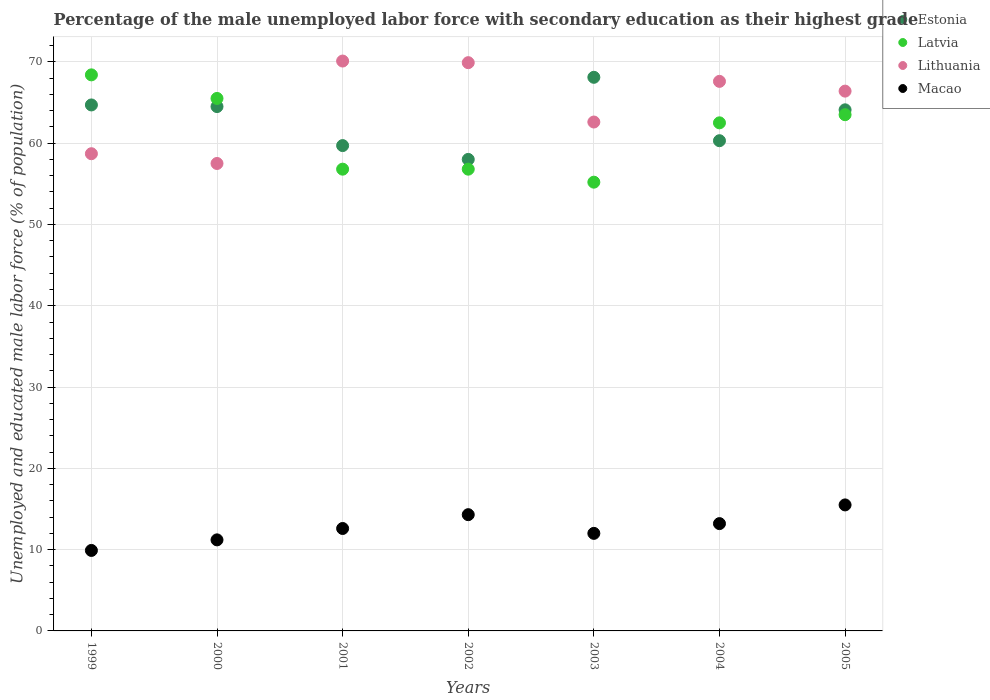Is the number of dotlines equal to the number of legend labels?
Your response must be concise. Yes. What is the percentage of the unemployed male labor force with secondary education in Macao in 2001?
Provide a succinct answer. 12.6. Across all years, what is the maximum percentage of the unemployed male labor force with secondary education in Estonia?
Keep it short and to the point. 68.1. In which year was the percentage of the unemployed male labor force with secondary education in Lithuania maximum?
Make the answer very short. 2001. In which year was the percentage of the unemployed male labor force with secondary education in Lithuania minimum?
Make the answer very short. 2000. What is the total percentage of the unemployed male labor force with secondary education in Lithuania in the graph?
Give a very brief answer. 452.8. What is the difference between the percentage of the unemployed male labor force with secondary education in Macao in 2003 and that in 2005?
Ensure brevity in your answer.  -3.5. What is the difference between the percentage of the unemployed male labor force with secondary education in Lithuania in 2004 and the percentage of the unemployed male labor force with secondary education in Macao in 2003?
Offer a terse response. 55.6. What is the average percentage of the unemployed male labor force with secondary education in Macao per year?
Make the answer very short. 12.67. In the year 2002, what is the difference between the percentage of the unemployed male labor force with secondary education in Macao and percentage of the unemployed male labor force with secondary education in Latvia?
Ensure brevity in your answer.  -42.5. In how many years, is the percentage of the unemployed male labor force with secondary education in Estonia greater than 68 %?
Offer a terse response. 1. What is the ratio of the percentage of the unemployed male labor force with secondary education in Estonia in 1999 to that in 2005?
Give a very brief answer. 1.01. Is the percentage of the unemployed male labor force with secondary education in Latvia in 1999 less than that in 2000?
Make the answer very short. No. What is the difference between the highest and the second highest percentage of the unemployed male labor force with secondary education in Macao?
Keep it short and to the point. 1.2. What is the difference between the highest and the lowest percentage of the unemployed male labor force with secondary education in Estonia?
Keep it short and to the point. 10.1. Is the sum of the percentage of the unemployed male labor force with secondary education in Estonia in 2000 and 2003 greater than the maximum percentage of the unemployed male labor force with secondary education in Lithuania across all years?
Offer a very short reply. Yes. Is it the case that in every year, the sum of the percentage of the unemployed male labor force with secondary education in Lithuania and percentage of the unemployed male labor force with secondary education in Estonia  is greater than the sum of percentage of the unemployed male labor force with secondary education in Latvia and percentage of the unemployed male labor force with secondary education in Macao?
Your response must be concise. No. Is it the case that in every year, the sum of the percentage of the unemployed male labor force with secondary education in Estonia and percentage of the unemployed male labor force with secondary education in Latvia  is greater than the percentage of the unemployed male labor force with secondary education in Lithuania?
Offer a terse response. Yes. Is the percentage of the unemployed male labor force with secondary education in Macao strictly greater than the percentage of the unemployed male labor force with secondary education in Estonia over the years?
Keep it short and to the point. No. How many dotlines are there?
Your response must be concise. 4. How many years are there in the graph?
Provide a succinct answer. 7. Are the values on the major ticks of Y-axis written in scientific E-notation?
Your answer should be very brief. No. Does the graph contain any zero values?
Your response must be concise. No. Does the graph contain grids?
Your response must be concise. Yes. Where does the legend appear in the graph?
Offer a very short reply. Top right. What is the title of the graph?
Your response must be concise. Percentage of the male unemployed labor force with secondary education as their highest grade. Does "Cuba" appear as one of the legend labels in the graph?
Offer a terse response. No. What is the label or title of the Y-axis?
Make the answer very short. Unemployed and educated male labor force (% of population). What is the Unemployed and educated male labor force (% of population) in Estonia in 1999?
Provide a short and direct response. 64.7. What is the Unemployed and educated male labor force (% of population) in Latvia in 1999?
Give a very brief answer. 68.4. What is the Unemployed and educated male labor force (% of population) in Lithuania in 1999?
Ensure brevity in your answer.  58.7. What is the Unemployed and educated male labor force (% of population) of Macao in 1999?
Keep it short and to the point. 9.9. What is the Unemployed and educated male labor force (% of population) in Estonia in 2000?
Offer a very short reply. 64.5. What is the Unemployed and educated male labor force (% of population) in Latvia in 2000?
Your answer should be very brief. 65.5. What is the Unemployed and educated male labor force (% of population) in Lithuania in 2000?
Offer a very short reply. 57.5. What is the Unemployed and educated male labor force (% of population) of Macao in 2000?
Give a very brief answer. 11.2. What is the Unemployed and educated male labor force (% of population) in Estonia in 2001?
Offer a very short reply. 59.7. What is the Unemployed and educated male labor force (% of population) in Latvia in 2001?
Provide a succinct answer. 56.8. What is the Unemployed and educated male labor force (% of population) in Lithuania in 2001?
Provide a short and direct response. 70.1. What is the Unemployed and educated male labor force (% of population) of Macao in 2001?
Your answer should be compact. 12.6. What is the Unemployed and educated male labor force (% of population) in Latvia in 2002?
Offer a very short reply. 56.8. What is the Unemployed and educated male labor force (% of population) in Lithuania in 2002?
Ensure brevity in your answer.  69.9. What is the Unemployed and educated male labor force (% of population) in Macao in 2002?
Offer a very short reply. 14.3. What is the Unemployed and educated male labor force (% of population) in Estonia in 2003?
Provide a short and direct response. 68.1. What is the Unemployed and educated male labor force (% of population) in Latvia in 2003?
Your answer should be compact. 55.2. What is the Unemployed and educated male labor force (% of population) of Lithuania in 2003?
Offer a terse response. 62.6. What is the Unemployed and educated male labor force (% of population) of Estonia in 2004?
Keep it short and to the point. 60.3. What is the Unemployed and educated male labor force (% of population) in Latvia in 2004?
Offer a terse response. 62.5. What is the Unemployed and educated male labor force (% of population) in Lithuania in 2004?
Provide a short and direct response. 67.6. What is the Unemployed and educated male labor force (% of population) of Macao in 2004?
Make the answer very short. 13.2. What is the Unemployed and educated male labor force (% of population) in Estonia in 2005?
Provide a short and direct response. 64.1. What is the Unemployed and educated male labor force (% of population) in Latvia in 2005?
Provide a succinct answer. 63.5. What is the Unemployed and educated male labor force (% of population) of Lithuania in 2005?
Provide a short and direct response. 66.4. What is the Unemployed and educated male labor force (% of population) in Macao in 2005?
Make the answer very short. 15.5. Across all years, what is the maximum Unemployed and educated male labor force (% of population) of Estonia?
Your answer should be compact. 68.1. Across all years, what is the maximum Unemployed and educated male labor force (% of population) of Latvia?
Your answer should be compact. 68.4. Across all years, what is the maximum Unemployed and educated male labor force (% of population) in Lithuania?
Make the answer very short. 70.1. Across all years, what is the minimum Unemployed and educated male labor force (% of population) of Latvia?
Offer a very short reply. 55.2. Across all years, what is the minimum Unemployed and educated male labor force (% of population) of Lithuania?
Your response must be concise. 57.5. Across all years, what is the minimum Unemployed and educated male labor force (% of population) in Macao?
Your answer should be compact. 9.9. What is the total Unemployed and educated male labor force (% of population) of Estonia in the graph?
Keep it short and to the point. 439.4. What is the total Unemployed and educated male labor force (% of population) in Latvia in the graph?
Your answer should be compact. 428.7. What is the total Unemployed and educated male labor force (% of population) in Lithuania in the graph?
Offer a terse response. 452.8. What is the total Unemployed and educated male labor force (% of population) of Macao in the graph?
Offer a terse response. 88.7. What is the difference between the Unemployed and educated male labor force (% of population) of Estonia in 1999 and that in 2000?
Give a very brief answer. 0.2. What is the difference between the Unemployed and educated male labor force (% of population) in Estonia in 1999 and that in 2001?
Give a very brief answer. 5. What is the difference between the Unemployed and educated male labor force (% of population) in Lithuania in 1999 and that in 2001?
Provide a succinct answer. -11.4. What is the difference between the Unemployed and educated male labor force (% of population) of Estonia in 1999 and that in 2002?
Your answer should be very brief. 6.7. What is the difference between the Unemployed and educated male labor force (% of population) of Estonia in 1999 and that in 2003?
Give a very brief answer. -3.4. What is the difference between the Unemployed and educated male labor force (% of population) of Latvia in 1999 and that in 2003?
Keep it short and to the point. 13.2. What is the difference between the Unemployed and educated male labor force (% of population) of Lithuania in 1999 and that in 2003?
Provide a succinct answer. -3.9. What is the difference between the Unemployed and educated male labor force (% of population) of Macao in 1999 and that in 2003?
Make the answer very short. -2.1. What is the difference between the Unemployed and educated male labor force (% of population) in Latvia in 1999 and that in 2004?
Ensure brevity in your answer.  5.9. What is the difference between the Unemployed and educated male labor force (% of population) in Lithuania in 1999 and that in 2004?
Ensure brevity in your answer.  -8.9. What is the difference between the Unemployed and educated male labor force (% of population) in Lithuania in 1999 and that in 2005?
Your response must be concise. -7.7. What is the difference between the Unemployed and educated male labor force (% of population) of Macao in 2000 and that in 2001?
Your response must be concise. -1.4. What is the difference between the Unemployed and educated male labor force (% of population) of Estonia in 2000 and that in 2003?
Offer a terse response. -3.6. What is the difference between the Unemployed and educated male labor force (% of population) of Lithuania in 2000 and that in 2003?
Give a very brief answer. -5.1. What is the difference between the Unemployed and educated male labor force (% of population) of Macao in 2000 and that in 2003?
Offer a terse response. -0.8. What is the difference between the Unemployed and educated male labor force (% of population) of Estonia in 2000 and that in 2004?
Your answer should be very brief. 4.2. What is the difference between the Unemployed and educated male labor force (% of population) in Macao in 2000 and that in 2004?
Provide a short and direct response. -2. What is the difference between the Unemployed and educated male labor force (% of population) of Lithuania in 2001 and that in 2002?
Your response must be concise. 0.2. What is the difference between the Unemployed and educated male labor force (% of population) in Lithuania in 2001 and that in 2003?
Offer a terse response. 7.5. What is the difference between the Unemployed and educated male labor force (% of population) of Estonia in 2001 and that in 2004?
Make the answer very short. -0.6. What is the difference between the Unemployed and educated male labor force (% of population) of Macao in 2001 and that in 2004?
Offer a very short reply. -0.6. What is the difference between the Unemployed and educated male labor force (% of population) of Estonia in 2001 and that in 2005?
Ensure brevity in your answer.  -4.4. What is the difference between the Unemployed and educated male labor force (% of population) in Lithuania in 2001 and that in 2005?
Offer a terse response. 3.7. What is the difference between the Unemployed and educated male labor force (% of population) of Macao in 2001 and that in 2005?
Give a very brief answer. -2.9. What is the difference between the Unemployed and educated male labor force (% of population) of Lithuania in 2002 and that in 2003?
Your response must be concise. 7.3. What is the difference between the Unemployed and educated male labor force (% of population) in Macao in 2002 and that in 2003?
Provide a short and direct response. 2.3. What is the difference between the Unemployed and educated male labor force (% of population) of Estonia in 2002 and that in 2004?
Provide a short and direct response. -2.3. What is the difference between the Unemployed and educated male labor force (% of population) of Latvia in 2002 and that in 2004?
Offer a terse response. -5.7. What is the difference between the Unemployed and educated male labor force (% of population) in Lithuania in 2002 and that in 2004?
Ensure brevity in your answer.  2.3. What is the difference between the Unemployed and educated male labor force (% of population) in Macao in 2002 and that in 2004?
Make the answer very short. 1.1. What is the difference between the Unemployed and educated male labor force (% of population) in Estonia in 2002 and that in 2005?
Your answer should be compact. -6.1. What is the difference between the Unemployed and educated male labor force (% of population) in Estonia in 2003 and that in 2005?
Keep it short and to the point. 4. What is the difference between the Unemployed and educated male labor force (% of population) of Latvia in 2003 and that in 2005?
Offer a very short reply. -8.3. What is the difference between the Unemployed and educated male labor force (% of population) in Lithuania in 2003 and that in 2005?
Offer a terse response. -3.8. What is the difference between the Unemployed and educated male labor force (% of population) in Estonia in 1999 and the Unemployed and educated male labor force (% of population) in Latvia in 2000?
Your response must be concise. -0.8. What is the difference between the Unemployed and educated male labor force (% of population) of Estonia in 1999 and the Unemployed and educated male labor force (% of population) of Lithuania in 2000?
Offer a very short reply. 7.2. What is the difference between the Unemployed and educated male labor force (% of population) of Estonia in 1999 and the Unemployed and educated male labor force (% of population) of Macao in 2000?
Offer a terse response. 53.5. What is the difference between the Unemployed and educated male labor force (% of population) in Latvia in 1999 and the Unemployed and educated male labor force (% of population) in Macao in 2000?
Make the answer very short. 57.2. What is the difference between the Unemployed and educated male labor force (% of population) of Lithuania in 1999 and the Unemployed and educated male labor force (% of population) of Macao in 2000?
Provide a short and direct response. 47.5. What is the difference between the Unemployed and educated male labor force (% of population) in Estonia in 1999 and the Unemployed and educated male labor force (% of population) in Lithuania in 2001?
Make the answer very short. -5.4. What is the difference between the Unemployed and educated male labor force (% of population) of Estonia in 1999 and the Unemployed and educated male labor force (% of population) of Macao in 2001?
Ensure brevity in your answer.  52.1. What is the difference between the Unemployed and educated male labor force (% of population) of Latvia in 1999 and the Unemployed and educated male labor force (% of population) of Macao in 2001?
Provide a succinct answer. 55.8. What is the difference between the Unemployed and educated male labor force (% of population) in Lithuania in 1999 and the Unemployed and educated male labor force (% of population) in Macao in 2001?
Provide a succinct answer. 46.1. What is the difference between the Unemployed and educated male labor force (% of population) in Estonia in 1999 and the Unemployed and educated male labor force (% of population) in Lithuania in 2002?
Make the answer very short. -5.2. What is the difference between the Unemployed and educated male labor force (% of population) of Estonia in 1999 and the Unemployed and educated male labor force (% of population) of Macao in 2002?
Your answer should be compact. 50.4. What is the difference between the Unemployed and educated male labor force (% of population) in Latvia in 1999 and the Unemployed and educated male labor force (% of population) in Macao in 2002?
Make the answer very short. 54.1. What is the difference between the Unemployed and educated male labor force (% of population) in Lithuania in 1999 and the Unemployed and educated male labor force (% of population) in Macao in 2002?
Offer a terse response. 44.4. What is the difference between the Unemployed and educated male labor force (% of population) in Estonia in 1999 and the Unemployed and educated male labor force (% of population) in Macao in 2003?
Keep it short and to the point. 52.7. What is the difference between the Unemployed and educated male labor force (% of population) of Latvia in 1999 and the Unemployed and educated male labor force (% of population) of Lithuania in 2003?
Offer a terse response. 5.8. What is the difference between the Unemployed and educated male labor force (% of population) in Latvia in 1999 and the Unemployed and educated male labor force (% of population) in Macao in 2003?
Your answer should be compact. 56.4. What is the difference between the Unemployed and educated male labor force (% of population) in Lithuania in 1999 and the Unemployed and educated male labor force (% of population) in Macao in 2003?
Ensure brevity in your answer.  46.7. What is the difference between the Unemployed and educated male labor force (% of population) of Estonia in 1999 and the Unemployed and educated male labor force (% of population) of Macao in 2004?
Provide a short and direct response. 51.5. What is the difference between the Unemployed and educated male labor force (% of population) of Latvia in 1999 and the Unemployed and educated male labor force (% of population) of Lithuania in 2004?
Make the answer very short. 0.8. What is the difference between the Unemployed and educated male labor force (% of population) of Latvia in 1999 and the Unemployed and educated male labor force (% of population) of Macao in 2004?
Ensure brevity in your answer.  55.2. What is the difference between the Unemployed and educated male labor force (% of population) in Lithuania in 1999 and the Unemployed and educated male labor force (% of population) in Macao in 2004?
Your answer should be very brief. 45.5. What is the difference between the Unemployed and educated male labor force (% of population) of Estonia in 1999 and the Unemployed and educated male labor force (% of population) of Latvia in 2005?
Keep it short and to the point. 1.2. What is the difference between the Unemployed and educated male labor force (% of population) in Estonia in 1999 and the Unemployed and educated male labor force (% of population) in Macao in 2005?
Offer a very short reply. 49.2. What is the difference between the Unemployed and educated male labor force (% of population) in Latvia in 1999 and the Unemployed and educated male labor force (% of population) in Macao in 2005?
Give a very brief answer. 52.9. What is the difference between the Unemployed and educated male labor force (% of population) of Lithuania in 1999 and the Unemployed and educated male labor force (% of population) of Macao in 2005?
Make the answer very short. 43.2. What is the difference between the Unemployed and educated male labor force (% of population) of Estonia in 2000 and the Unemployed and educated male labor force (% of population) of Lithuania in 2001?
Keep it short and to the point. -5.6. What is the difference between the Unemployed and educated male labor force (% of population) in Estonia in 2000 and the Unemployed and educated male labor force (% of population) in Macao in 2001?
Keep it short and to the point. 51.9. What is the difference between the Unemployed and educated male labor force (% of population) of Latvia in 2000 and the Unemployed and educated male labor force (% of population) of Macao in 2001?
Provide a short and direct response. 52.9. What is the difference between the Unemployed and educated male labor force (% of population) of Lithuania in 2000 and the Unemployed and educated male labor force (% of population) of Macao in 2001?
Make the answer very short. 44.9. What is the difference between the Unemployed and educated male labor force (% of population) of Estonia in 2000 and the Unemployed and educated male labor force (% of population) of Lithuania in 2002?
Keep it short and to the point. -5.4. What is the difference between the Unemployed and educated male labor force (% of population) in Estonia in 2000 and the Unemployed and educated male labor force (% of population) in Macao in 2002?
Offer a very short reply. 50.2. What is the difference between the Unemployed and educated male labor force (% of population) of Latvia in 2000 and the Unemployed and educated male labor force (% of population) of Macao in 2002?
Make the answer very short. 51.2. What is the difference between the Unemployed and educated male labor force (% of population) of Lithuania in 2000 and the Unemployed and educated male labor force (% of population) of Macao in 2002?
Your answer should be compact. 43.2. What is the difference between the Unemployed and educated male labor force (% of population) in Estonia in 2000 and the Unemployed and educated male labor force (% of population) in Latvia in 2003?
Keep it short and to the point. 9.3. What is the difference between the Unemployed and educated male labor force (% of population) of Estonia in 2000 and the Unemployed and educated male labor force (% of population) of Macao in 2003?
Ensure brevity in your answer.  52.5. What is the difference between the Unemployed and educated male labor force (% of population) of Latvia in 2000 and the Unemployed and educated male labor force (% of population) of Macao in 2003?
Ensure brevity in your answer.  53.5. What is the difference between the Unemployed and educated male labor force (% of population) of Lithuania in 2000 and the Unemployed and educated male labor force (% of population) of Macao in 2003?
Offer a terse response. 45.5. What is the difference between the Unemployed and educated male labor force (% of population) in Estonia in 2000 and the Unemployed and educated male labor force (% of population) in Latvia in 2004?
Provide a short and direct response. 2. What is the difference between the Unemployed and educated male labor force (% of population) in Estonia in 2000 and the Unemployed and educated male labor force (% of population) in Macao in 2004?
Provide a short and direct response. 51.3. What is the difference between the Unemployed and educated male labor force (% of population) in Latvia in 2000 and the Unemployed and educated male labor force (% of population) in Lithuania in 2004?
Provide a succinct answer. -2.1. What is the difference between the Unemployed and educated male labor force (% of population) in Latvia in 2000 and the Unemployed and educated male labor force (% of population) in Macao in 2004?
Give a very brief answer. 52.3. What is the difference between the Unemployed and educated male labor force (% of population) of Lithuania in 2000 and the Unemployed and educated male labor force (% of population) of Macao in 2004?
Provide a succinct answer. 44.3. What is the difference between the Unemployed and educated male labor force (% of population) of Estonia in 2000 and the Unemployed and educated male labor force (% of population) of Lithuania in 2005?
Your answer should be very brief. -1.9. What is the difference between the Unemployed and educated male labor force (% of population) of Latvia in 2000 and the Unemployed and educated male labor force (% of population) of Lithuania in 2005?
Ensure brevity in your answer.  -0.9. What is the difference between the Unemployed and educated male labor force (% of population) in Estonia in 2001 and the Unemployed and educated male labor force (% of population) in Latvia in 2002?
Your answer should be compact. 2.9. What is the difference between the Unemployed and educated male labor force (% of population) in Estonia in 2001 and the Unemployed and educated male labor force (% of population) in Lithuania in 2002?
Give a very brief answer. -10.2. What is the difference between the Unemployed and educated male labor force (% of population) of Estonia in 2001 and the Unemployed and educated male labor force (% of population) of Macao in 2002?
Provide a succinct answer. 45.4. What is the difference between the Unemployed and educated male labor force (% of population) of Latvia in 2001 and the Unemployed and educated male labor force (% of population) of Macao in 2002?
Make the answer very short. 42.5. What is the difference between the Unemployed and educated male labor force (% of population) of Lithuania in 2001 and the Unemployed and educated male labor force (% of population) of Macao in 2002?
Keep it short and to the point. 55.8. What is the difference between the Unemployed and educated male labor force (% of population) in Estonia in 2001 and the Unemployed and educated male labor force (% of population) in Macao in 2003?
Offer a very short reply. 47.7. What is the difference between the Unemployed and educated male labor force (% of population) of Latvia in 2001 and the Unemployed and educated male labor force (% of population) of Lithuania in 2003?
Ensure brevity in your answer.  -5.8. What is the difference between the Unemployed and educated male labor force (% of population) of Latvia in 2001 and the Unemployed and educated male labor force (% of population) of Macao in 2003?
Provide a short and direct response. 44.8. What is the difference between the Unemployed and educated male labor force (% of population) in Lithuania in 2001 and the Unemployed and educated male labor force (% of population) in Macao in 2003?
Keep it short and to the point. 58.1. What is the difference between the Unemployed and educated male labor force (% of population) in Estonia in 2001 and the Unemployed and educated male labor force (% of population) in Macao in 2004?
Make the answer very short. 46.5. What is the difference between the Unemployed and educated male labor force (% of population) in Latvia in 2001 and the Unemployed and educated male labor force (% of population) in Lithuania in 2004?
Make the answer very short. -10.8. What is the difference between the Unemployed and educated male labor force (% of population) in Latvia in 2001 and the Unemployed and educated male labor force (% of population) in Macao in 2004?
Give a very brief answer. 43.6. What is the difference between the Unemployed and educated male labor force (% of population) of Lithuania in 2001 and the Unemployed and educated male labor force (% of population) of Macao in 2004?
Offer a terse response. 56.9. What is the difference between the Unemployed and educated male labor force (% of population) in Estonia in 2001 and the Unemployed and educated male labor force (% of population) in Latvia in 2005?
Give a very brief answer. -3.8. What is the difference between the Unemployed and educated male labor force (% of population) of Estonia in 2001 and the Unemployed and educated male labor force (% of population) of Macao in 2005?
Ensure brevity in your answer.  44.2. What is the difference between the Unemployed and educated male labor force (% of population) of Latvia in 2001 and the Unemployed and educated male labor force (% of population) of Lithuania in 2005?
Offer a very short reply. -9.6. What is the difference between the Unemployed and educated male labor force (% of population) of Latvia in 2001 and the Unemployed and educated male labor force (% of population) of Macao in 2005?
Your response must be concise. 41.3. What is the difference between the Unemployed and educated male labor force (% of population) of Lithuania in 2001 and the Unemployed and educated male labor force (% of population) of Macao in 2005?
Provide a short and direct response. 54.6. What is the difference between the Unemployed and educated male labor force (% of population) of Estonia in 2002 and the Unemployed and educated male labor force (% of population) of Latvia in 2003?
Your answer should be compact. 2.8. What is the difference between the Unemployed and educated male labor force (% of population) in Estonia in 2002 and the Unemployed and educated male labor force (% of population) in Lithuania in 2003?
Provide a short and direct response. -4.6. What is the difference between the Unemployed and educated male labor force (% of population) in Estonia in 2002 and the Unemployed and educated male labor force (% of population) in Macao in 2003?
Make the answer very short. 46. What is the difference between the Unemployed and educated male labor force (% of population) of Latvia in 2002 and the Unemployed and educated male labor force (% of population) of Lithuania in 2003?
Offer a terse response. -5.8. What is the difference between the Unemployed and educated male labor force (% of population) in Latvia in 2002 and the Unemployed and educated male labor force (% of population) in Macao in 2003?
Your answer should be compact. 44.8. What is the difference between the Unemployed and educated male labor force (% of population) in Lithuania in 2002 and the Unemployed and educated male labor force (% of population) in Macao in 2003?
Ensure brevity in your answer.  57.9. What is the difference between the Unemployed and educated male labor force (% of population) in Estonia in 2002 and the Unemployed and educated male labor force (% of population) in Latvia in 2004?
Provide a succinct answer. -4.5. What is the difference between the Unemployed and educated male labor force (% of population) of Estonia in 2002 and the Unemployed and educated male labor force (% of population) of Macao in 2004?
Keep it short and to the point. 44.8. What is the difference between the Unemployed and educated male labor force (% of population) of Latvia in 2002 and the Unemployed and educated male labor force (% of population) of Macao in 2004?
Keep it short and to the point. 43.6. What is the difference between the Unemployed and educated male labor force (% of population) in Lithuania in 2002 and the Unemployed and educated male labor force (% of population) in Macao in 2004?
Your response must be concise. 56.7. What is the difference between the Unemployed and educated male labor force (% of population) of Estonia in 2002 and the Unemployed and educated male labor force (% of population) of Latvia in 2005?
Ensure brevity in your answer.  -5.5. What is the difference between the Unemployed and educated male labor force (% of population) of Estonia in 2002 and the Unemployed and educated male labor force (% of population) of Lithuania in 2005?
Provide a succinct answer. -8.4. What is the difference between the Unemployed and educated male labor force (% of population) in Estonia in 2002 and the Unemployed and educated male labor force (% of population) in Macao in 2005?
Your answer should be very brief. 42.5. What is the difference between the Unemployed and educated male labor force (% of population) in Latvia in 2002 and the Unemployed and educated male labor force (% of population) in Macao in 2005?
Your answer should be compact. 41.3. What is the difference between the Unemployed and educated male labor force (% of population) in Lithuania in 2002 and the Unemployed and educated male labor force (% of population) in Macao in 2005?
Provide a succinct answer. 54.4. What is the difference between the Unemployed and educated male labor force (% of population) in Estonia in 2003 and the Unemployed and educated male labor force (% of population) in Latvia in 2004?
Your answer should be compact. 5.6. What is the difference between the Unemployed and educated male labor force (% of population) in Estonia in 2003 and the Unemployed and educated male labor force (% of population) in Macao in 2004?
Provide a succinct answer. 54.9. What is the difference between the Unemployed and educated male labor force (% of population) of Latvia in 2003 and the Unemployed and educated male labor force (% of population) of Macao in 2004?
Offer a terse response. 42. What is the difference between the Unemployed and educated male labor force (% of population) in Lithuania in 2003 and the Unemployed and educated male labor force (% of population) in Macao in 2004?
Provide a short and direct response. 49.4. What is the difference between the Unemployed and educated male labor force (% of population) in Estonia in 2003 and the Unemployed and educated male labor force (% of population) in Latvia in 2005?
Make the answer very short. 4.6. What is the difference between the Unemployed and educated male labor force (% of population) of Estonia in 2003 and the Unemployed and educated male labor force (% of population) of Lithuania in 2005?
Make the answer very short. 1.7. What is the difference between the Unemployed and educated male labor force (% of population) in Estonia in 2003 and the Unemployed and educated male labor force (% of population) in Macao in 2005?
Make the answer very short. 52.6. What is the difference between the Unemployed and educated male labor force (% of population) of Latvia in 2003 and the Unemployed and educated male labor force (% of population) of Lithuania in 2005?
Your answer should be compact. -11.2. What is the difference between the Unemployed and educated male labor force (% of population) of Latvia in 2003 and the Unemployed and educated male labor force (% of population) of Macao in 2005?
Your answer should be compact. 39.7. What is the difference between the Unemployed and educated male labor force (% of population) of Lithuania in 2003 and the Unemployed and educated male labor force (% of population) of Macao in 2005?
Give a very brief answer. 47.1. What is the difference between the Unemployed and educated male labor force (% of population) of Estonia in 2004 and the Unemployed and educated male labor force (% of population) of Latvia in 2005?
Make the answer very short. -3.2. What is the difference between the Unemployed and educated male labor force (% of population) in Estonia in 2004 and the Unemployed and educated male labor force (% of population) in Lithuania in 2005?
Offer a very short reply. -6.1. What is the difference between the Unemployed and educated male labor force (% of population) of Estonia in 2004 and the Unemployed and educated male labor force (% of population) of Macao in 2005?
Give a very brief answer. 44.8. What is the difference between the Unemployed and educated male labor force (% of population) of Latvia in 2004 and the Unemployed and educated male labor force (% of population) of Macao in 2005?
Provide a short and direct response. 47. What is the difference between the Unemployed and educated male labor force (% of population) of Lithuania in 2004 and the Unemployed and educated male labor force (% of population) of Macao in 2005?
Provide a short and direct response. 52.1. What is the average Unemployed and educated male labor force (% of population) of Estonia per year?
Give a very brief answer. 62.77. What is the average Unemployed and educated male labor force (% of population) of Latvia per year?
Provide a short and direct response. 61.24. What is the average Unemployed and educated male labor force (% of population) in Lithuania per year?
Keep it short and to the point. 64.69. What is the average Unemployed and educated male labor force (% of population) in Macao per year?
Give a very brief answer. 12.67. In the year 1999, what is the difference between the Unemployed and educated male labor force (% of population) in Estonia and Unemployed and educated male labor force (% of population) in Lithuania?
Offer a terse response. 6. In the year 1999, what is the difference between the Unemployed and educated male labor force (% of population) of Estonia and Unemployed and educated male labor force (% of population) of Macao?
Offer a terse response. 54.8. In the year 1999, what is the difference between the Unemployed and educated male labor force (% of population) of Latvia and Unemployed and educated male labor force (% of population) of Lithuania?
Your answer should be very brief. 9.7. In the year 1999, what is the difference between the Unemployed and educated male labor force (% of population) in Latvia and Unemployed and educated male labor force (% of population) in Macao?
Give a very brief answer. 58.5. In the year 1999, what is the difference between the Unemployed and educated male labor force (% of population) of Lithuania and Unemployed and educated male labor force (% of population) of Macao?
Ensure brevity in your answer.  48.8. In the year 2000, what is the difference between the Unemployed and educated male labor force (% of population) in Estonia and Unemployed and educated male labor force (% of population) in Macao?
Make the answer very short. 53.3. In the year 2000, what is the difference between the Unemployed and educated male labor force (% of population) in Latvia and Unemployed and educated male labor force (% of population) in Lithuania?
Your answer should be very brief. 8. In the year 2000, what is the difference between the Unemployed and educated male labor force (% of population) of Latvia and Unemployed and educated male labor force (% of population) of Macao?
Keep it short and to the point. 54.3. In the year 2000, what is the difference between the Unemployed and educated male labor force (% of population) in Lithuania and Unemployed and educated male labor force (% of population) in Macao?
Offer a very short reply. 46.3. In the year 2001, what is the difference between the Unemployed and educated male labor force (% of population) of Estonia and Unemployed and educated male labor force (% of population) of Macao?
Your response must be concise. 47.1. In the year 2001, what is the difference between the Unemployed and educated male labor force (% of population) of Latvia and Unemployed and educated male labor force (% of population) of Macao?
Provide a succinct answer. 44.2. In the year 2001, what is the difference between the Unemployed and educated male labor force (% of population) of Lithuania and Unemployed and educated male labor force (% of population) of Macao?
Your answer should be compact. 57.5. In the year 2002, what is the difference between the Unemployed and educated male labor force (% of population) in Estonia and Unemployed and educated male labor force (% of population) in Latvia?
Offer a very short reply. 1.2. In the year 2002, what is the difference between the Unemployed and educated male labor force (% of population) in Estonia and Unemployed and educated male labor force (% of population) in Lithuania?
Ensure brevity in your answer.  -11.9. In the year 2002, what is the difference between the Unemployed and educated male labor force (% of population) in Estonia and Unemployed and educated male labor force (% of population) in Macao?
Offer a very short reply. 43.7. In the year 2002, what is the difference between the Unemployed and educated male labor force (% of population) of Latvia and Unemployed and educated male labor force (% of population) of Macao?
Your answer should be compact. 42.5. In the year 2002, what is the difference between the Unemployed and educated male labor force (% of population) of Lithuania and Unemployed and educated male labor force (% of population) of Macao?
Offer a very short reply. 55.6. In the year 2003, what is the difference between the Unemployed and educated male labor force (% of population) of Estonia and Unemployed and educated male labor force (% of population) of Latvia?
Your answer should be compact. 12.9. In the year 2003, what is the difference between the Unemployed and educated male labor force (% of population) in Estonia and Unemployed and educated male labor force (% of population) in Lithuania?
Provide a short and direct response. 5.5. In the year 2003, what is the difference between the Unemployed and educated male labor force (% of population) in Estonia and Unemployed and educated male labor force (% of population) in Macao?
Offer a terse response. 56.1. In the year 2003, what is the difference between the Unemployed and educated male labor force (% of population) of Latvia and Unemployed and educated male labor force (% of population) of Macao?
Make the answer very short. 43.2. In the year 2003, what is the difference between the Unemployed and educated male labor force (% of population) in Lithuania and Unemployed and educated male labor force (% of population) in Macao?
Give a very brief answer. 50.6. In the year 2004, what is the difference between the Unemployed and educated male labor force (% of population) of Estonia and Unemployed and educated male labor force (% of population) of Lithuania?
Offer a very short reply. -7.3. In the year 2004, what is the difference between the Unemployed and educated male labor force (% of population) of Estonia and Unemployed and educated male labor force (% of population) of Macao?
Keep it short and to the point. 47.1. In the year 2004, what is the difference between the Unemployed and educated male labor force (% of population) in Latvia and Unemployed and educated male labor force (% of population) in Lithuania?
Keep it short and to the point. -5.1. In the year 2004, what is the difference between the Unemployed and educated male labor force (% of population) of Latvia and Unemployed and educated male labor force (% of population) of Macao?
Make the answer very short. 49.3. In the year 2004, what is the difference between the Unemployed and educated male labor force (% of population) in Lithuania and Unemployed and educated male labor force (% of population) in Macao?
Keep it short and to the point. 54.4. In the year 2005, what is the difference between the Unemployed and educated male labor force (% of population) in Estonia and Unemployed and educated male labor force (% of population) in Lithuania?
Give a very brief answer. -2.3. In the year 2005, what is the difference between the Unemployed and educated male labor force (% of population) of Estonia and Unemployed and educated male labor force (% of population) of Macao?
Ensure brevity in your answer.  48.6. In the year 2005, what is the difference between the Unemployed and educated male labor force (% of population) of Lithuania and Unemployed and educated male labor force (% of population) of Macao?
Your answer should be compact. 50.9. What is the ratio of the Unemployed and educated male labor force (% of population) of Latvia in 1999 to that in 2000?
Provide a short and direct response. 1.04. What is the ratio of the Unemployed and educated male labor force (% of population) of Lithuania in 1999 to that in 2000?
Offer a terse response. 1.02. What is the ratio of the Unemployed and educated male labor force (% of population) in Macao in 1999 to that in 2000?
Keep it short and to the point. 0.88. What is the ratio of the Unemployed and educated male labor force (% of population) of Estonia in 1999 to that in 2001?
Make the answer very short. 1.08. What is the ratio of the Unemployed and educated male labor force (% of population) in Latvia in 1999 to that in 2001?
Make the answer very short. 1.2. What is the ratio of the Unemployed and educated male labor force (% of population) in Lithuania in 1999 to that in 2001?
Make the answer very short. 0.84. What is the ratio of the Unemployed and educated male labor force (% of population) in Macao in 1999 to that in 2001?
Keep it short and to the point. 0.79. What is the ratio of the Unemployed and educated male labor force (% of population) in Estonia in 1999 to that in 2002?
Your answer should be compact. 1.12. What is the ratio of the Unemployed and educated male labor force (% of population) in Latvia in 1999 to that in 2002?
Provide a succinct answer. 1.2. What is the ratio of the Unemployed and educated male labor force (% of population) of Lithuania in 1999 to that in 2002?
Ensure brevity in your answer.  0.84. What is the ratio of the Unemployed and educated male labor force (% of population) in Macao in 1999 to that in 2002?
Make the answer very short. 0.69. What is the ratio of the Unemployed and educated male labor force (% of population) in Estonia in 1999 to that in 2003?
Offer a very short reply. 0.95. What is the ratio of the Unemployed and educated male labor force (% of population) in Latvia in 1999 to that in 2003?
Give a very brief answer. 1.24. What is the ratio of the Unemployed and educated male labor force (% of population) of Lithuania in 1999 to that in 2003?
Offer a terse response. 0.94. What is the ratio of the Unemployed and educated male labor force (% of population) in Macao in 1999 to that in 2003?
Your answer should be very brief. 0.82. What is the ratio of the Unemployed and educated male labor force (% of population) in Estonia in 1999 to that in 2004?
Offer a very short reply. 1.07. What is the ratio of the Unemployed and educated male labor force (% of population) in Latvia in 1999 to that in 2004?
Provide a short and direct response. 1.09. What is the ratio of the Unemployed and educated male labor force (% of population) of Lithuania in 1999 to that in 2004?
Offer a very short reply. 0.87. What is the ratio of the Unemployed and educated male labor force (% of population) of Macao in 1999 to that in 2004?
Keep it short and to the point. 0.75. What is the ratio of the Unemployed and educated male labor force (% of population) of Estonia in 1999 to that in 2005?
Make the answer very short. 1.01. What is the ratio of the Unemployed and educated male labor force (% of population) of Latvia in 1999 to that in 2005?
Keep it short and to the point. 1.08. What is the ratio of the Unemployed and educated male labor force (% of population) in Lithuania in 1999 to that in 2005?
Your answer should be very brief. 0.88. What is the ratio of the Unemployed and educated male labor force (% of population) in Macao in 1999 to that in 2005?
Provide a short and direct response. 0.64. What is the ratio of the Unemployed and educated male labor force (% of population) in Estonia in 2000 to that in 2001?
Provide a succinct answer. 1.08. What is the ratio of the Unemployed and educated male labor force (% of population) in Latvia in 2000 to that in 2001?
Your answer should be compact. 1.15. What is the ratio of the Unemployed and educated male labor force (% of population) in Lithuania in 2000 to that in 2001?
Offer a terse response. 0.82. What is the ratio of the Unemployed and educated male labor force (% of population) in Macao in 2000 to that in 2001?
Your answer should be compact. 0.89. What is the ratio of the Unemployed and educated male labor force (% of population) in Estonia in 2000 to that in 2002?
Provide a short and direct response. 1.11. What is the ratio of the Unemployed and educated male labor force (% of population) of Latvia in 2000 to that in 2002?
Keep it short and to the point. 1.15. What is the ratio of the Unemployed and educated male labor force (% of population) in Lithuania in 2000 to that in 2002?
Provide a succinct answer. 0.82. What is the ratio of the Unemployed and educated male labor force (% of population) of Macao in 2000 to that in 2002?
Provide a short and direct response. 0.78. What is the ratio of the Unemployed and educated male labor force (% of population) of Estonia in 2000 to that in 2003?
Offer a very short reply. 0.95. What is the ratio of the Unemployed and educated male labor force (% of population) of Latvia in 2000 to that in 2003?
Offer a very short reply. 1.19. What is the ratio of the Unemployed and educated male labor force (% of population) of Lithuania in 2000 to that in 2003?
Give a very brief answer. 0.92. What is the ratio of the Unemployed and educated male labor force (% of population) of Macao in 2000 to that in 2003?
Your answer should be compact. 0.93. What is the ratio of the Unemployed and educated male labor force (% of population) of Estonia in 2000 to that in 2004?
Give a very brief answer. 1.07. What is the ratio of the Unemployed and educated male labor force (% of population) in Latvia in 2000 to that in 2004?
Your answer should be compact. 1.05. What is the ratio of the Unemployed and educated male labor force (% of population) of Lithuania in 2000 to that in 2004?
Your answer should be very brief. 0.85. What is the ratio of the Unemployed and educated male labor force (% of population) of Macao in 2000 to that in 2004?
Keep it short and to the point. 0.85. What is the ratio of the Unemployed and educated male labor force (% of population) in Estonia in 2000 to that in 2005?
Provide a short and direct response. 1.01. What is the ratio of the Unemployed and educated male labor force (% of population) in Latvia in 2000 to that in 2005?
Offer a terse response. 1.03. What is the ratio of the Unemployed and educated male labor force (% of population) in Lithuania in 2000 to that in 2005?
Your answer should be compact. 0.87. What is the ratio of the Unemployed and educated male labor force (% of population) of Macao in 2000 to that in 2005?
Offer a very short reply. 0.72. What is the ratio of the Unemployed and educated male labor force (% of population) in Estonia in 2001 to that in 2002?
Your response must be concise. 1.03. What is the ratio of the Unemployed and educated male labor force (% of population) in Macao in 2001 to that in 2002?
Your answer should be very brief. 0.88. What is the ratio of the Unemployed and educated male labor force (% of population) of Estonia in 2001 to that in 2003?
Ensure brevity in your answer.  0.88. What is the ratio of the Unemployed and educated male labor force (% of population) of Lithuania in 2001 to that in 2003?
Provide a succinct answer. 1.12. What is the ratio of the Unemployed and educated male labor force (% of population) of Macao in 2001 to that in 2003?
Your answer should be very brief. 1.05. What is the ratio of the Unemployed and educated male labor force (% of population) in Estonia in 2001 to that in 2004?
Your response must be concise. 0.99. What is the ratio of the Unemployed and educated male labor force (% of population) in Latvia in 2001 to that in 2004?
Your answer should be compact. 0.91. What is the ratio of the Unemployed and educated male labor force (% of population) of Macao in 2001 to that in 2004?
Provide a succinct answer. 0.95. What is the ratio of the Unemployed and educated male labor force (% of population) in Estonia in 2001 to that in 2005?
Provide a succinct answer. 0.93. What is the ratio of the Unemployed and educated male labor force (% of population) of Latvia in 2001 to that in 2005?
Offer a terse response. 0.89. What is the ratio of the Unemployed and educated male labor force (% of population) of Lithuania in 2001 to that in 2005?
Your response must be concise. 1.06. What is the ratio of the Unemployed and educated male labor force (% of population) of Macao in 2001 to that in 2005?
Ensure brevity in your answer.  0.81. What is the ratio of the Unemployed and educated male labor force (% of population) of Estonia in 2002 to that in 2003?
Offer a very short reply. 0.85. What is the ratio of the Unemployed and educated male labor force (% of population) in Latvia in 2002 to that in 2003?
Offer a very short reply. 1.03. What is the ratio of the Unemployed and educated male labor force (% of population) in Lithuania in 2002 to that in 2003?
Ensure brevity in your answer.  1.12. What is the ratio of the Unemployed and educated male labor force (% of population) in Macao in 2002 to that in 2003?
Your response must be concise. 1.19. What is the ratio of the Unemployed and educated male labor force (% of population) in Estonia in 2002 to that in 2004?
Keep it short and to the point. 0.96. What is the ratio of the Unemployed and educated male labor force (% of population) of Latvia in 2002 to that in 2004?
Your response must be concise. 0.91. What is the ratio of the Unemployed and educated male labor force (% of population) of Lithuania in 2002 to that in 2004?
Ensure brevity in your answer.  1.03. What is the ratio of the Unemployed and educated male labor force (% of population) of Macao in 2002 to that in 2004?
Offer a very short reply. 1.08. What is the ratio of the Unemployed and educated male labor force (% of population) in Estonia in 2002 to that in 2005?
Your answer should be compact. 0.9. What is the ratio of the Unemployed and educated male labor force (% of population) of Latvia in 2002 to that in 2005?
Your answer should be compact. 0.89. What is the ratio of the Unemployed and educated male labor force (% of population) in Lithuania in 2002 to that in 2005?
Give a very brief answer. 1.05. What is the ratio of the Unemployed and educated male labor force (% of population) of Macao in 2002 to that in 2005?
Offer a terse response. 0.92. What is the ratio of the Unemployed and educated male labor force (% of population) of Estonia in 2003 to that in 2004?
Keep it short and to the point. 1.13. What is the ratio of the Unemployed and educated male labor force (% of population) in Latvia in 2003 to that in 2004?
Offer a very short reply. 0.88. What is the ratio of the Unemployed and educated male labor force (% of population) in Lithuania in 2003 to that in 2004?
Give a very brief answer. 0.93. What is the ratio of the Unemployed and educated male labor force (% of population) in Estonia in 2003 to that in 2005?
Your answer should be very brief. 1.06. What is the ratio of the Unemployed and educated male labor force (% of population) of Latvia in 2003 to that in 2005?
Your response must be concise. 0.87. What is the ratio of the Unemployed and educated male labor force (% of population) of Lithuania in 2003 to that in 2005?
Your response must be concise. 0.94. What is the ratio of the Unemployed and educated male labor force (% of population) of Macao in 2003 to that in 2005?
Offer a terse response. 0.77. What is the ratio of the Unemployed and educated male labor force (% of population) in Estonia in 2004 to that in 2005?
Your answer should be very brief. 0.94. What is the ratio of the Unemployed and educated male labor force (% of population) in Latvia in 2004 to that in 2005?
Your answer should be very brief. 0.98. What is the ratio of the Unemployed and educated male labor force (% of population) of Lithuania in 2004 to that in 2005?
Your answer should be compact. 1.02. What is the ratio of the Unemployed and educated male labor force (% of population) in Macao in 2004 to that in 2005?
Keep it short and to the point. 0.85. What is the difference between the highest and the second highest Unemployed and educated male labor force (% of population) in Estonia?
Provide a succinct answer. 3.4. What is the difference between the highest and the second highest Unemployed and educated male labor force (% of population) of Latvia?
Your answer should be very brief. 2.9. What is the difference between the highest and the second highest Unemployed and educated male labor force (% of population) in Lithuania?
Offer a very short reply. 0.2. What is the difference between the highest and the lowest Unemployed and educated male labor force (% of population) in Latvia?
Make the answer very short. 13.2. What is the difference between the highest and the lowest Unemployed and educated male labor force (% of population) of Macao?
Make the answer very short. 5.6. 